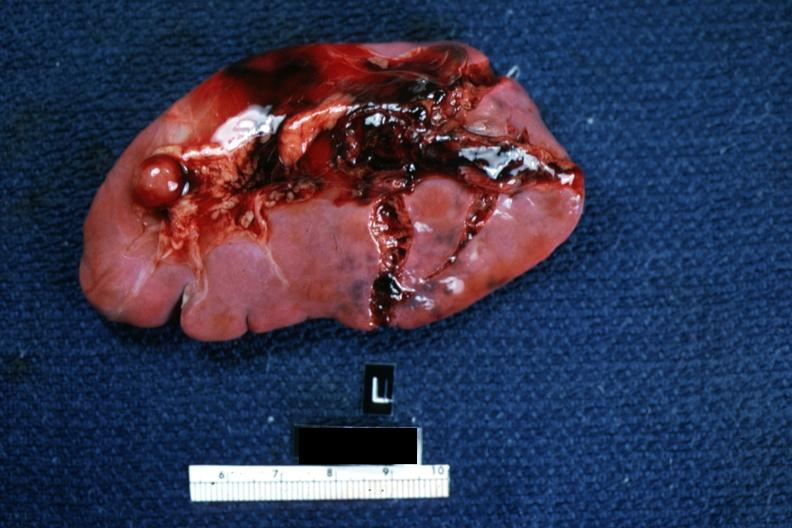what is present?
Answer the question using a single word or phrase. Spleen 